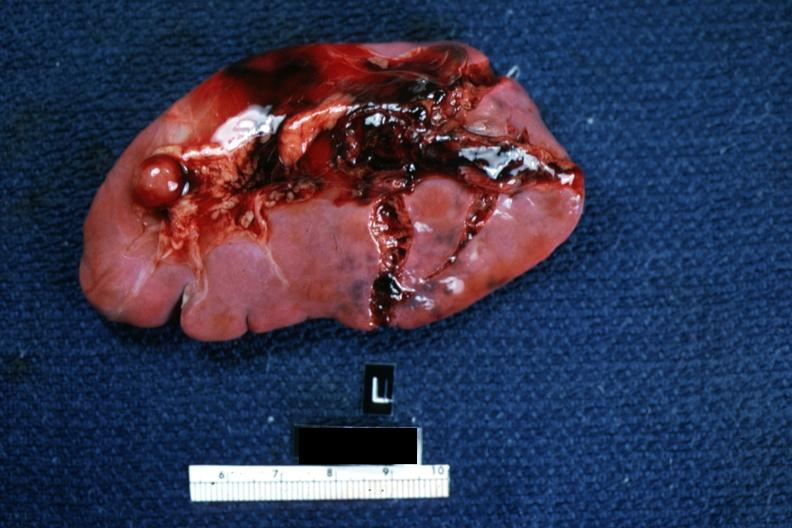what is present?
Answer the question using a single word or phrase. Spleen 